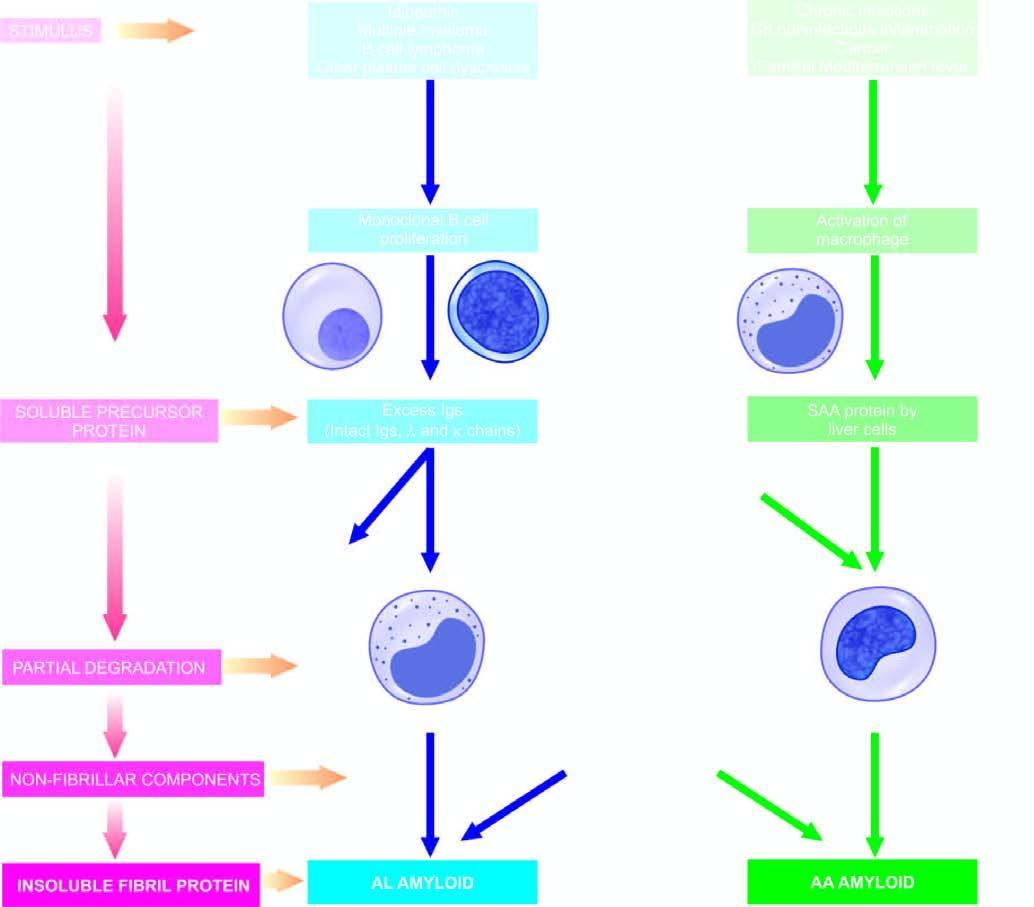does the interstitial vasculature show general schematic representation common to both major forms of amyloidogenesis?
Answer the question using a single word or phrase. No 